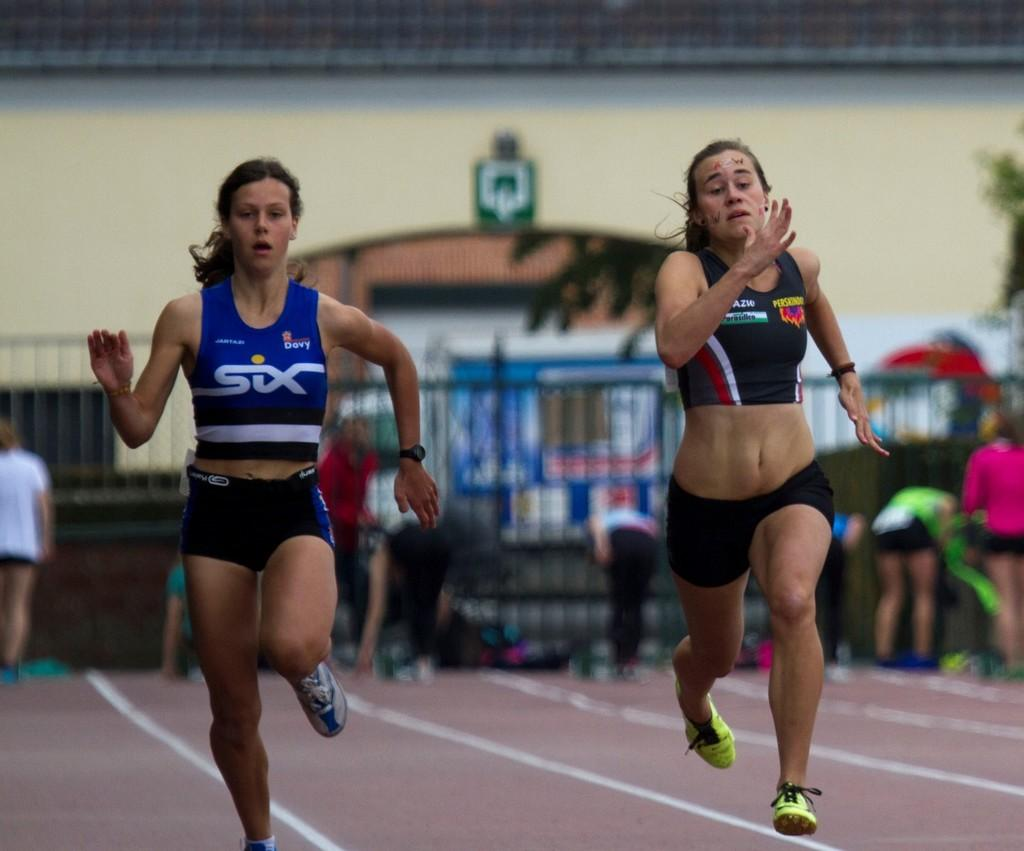<image>
Give a short and clear explanation of the subsequent image. Two women racing with one wearing a top which says SIX on it. 